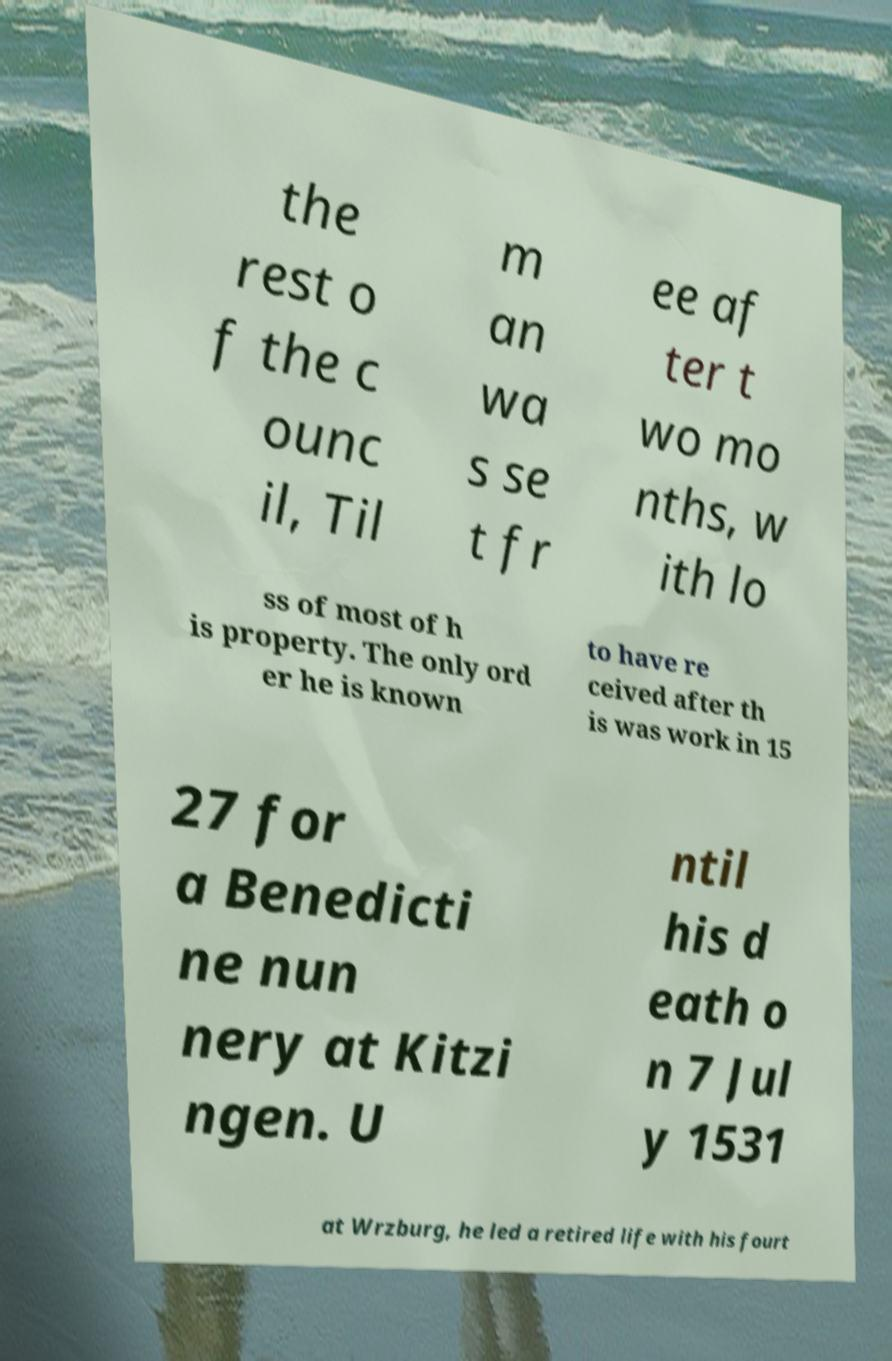Could you extract and type out the text from this image? the rest o f the c ounc il, Til m an wa s se t fr ee af ter t wo mo nths, w ith lo ss of most of h is property. The only ord er he is known to have re ceived after th is was work in 15 27 for a Benedicti ne nun nery at Kitzi ngen. U ntil his d eath o n 7 Jul y 1531 at Wrzburg, he led a retired life with his fourt 